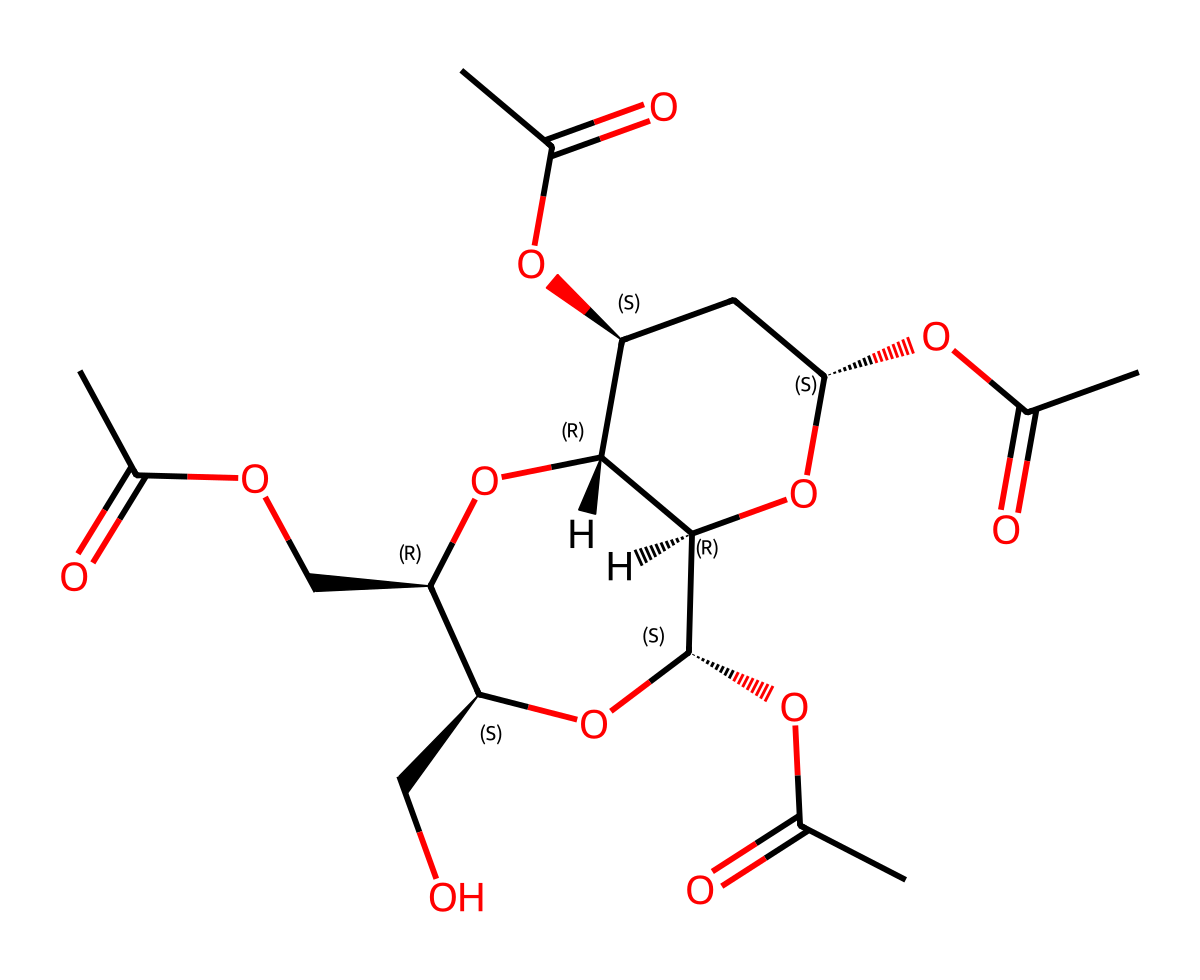What is the total number of carbon atoms in the structure? By examining the SMILES representation, count the carbon atoms indicated by "C" and "C@" in the structure. There are 12 carbon atoms in total.
Answer: 12 How many ester functional groups are present in this molecule? The structure can be analyzed for ester groups, which are characterized by the presence of the -COO- grouping. By identifying these functional groups in the structure, we can find 4 ester groups.
Answer: 4 What is the maximum number of hydroxyl (-OH) groups in the structure? Examine the structure for hydroxyl groups, looking specifically for the -OH functional group. In this case, there are 6 hydroxyl groups present in the structure.
Answer: 6 Is this molecule biodegradable? Given that the molecule is cellulose acetate, which is a biodegradable ester used in environmentally friendly applications, we can confirm that, yes, it is biodegradable.
Answer: yes What type of chemical is cellulose acetate? Cellulose acetate is identified as an ester because its structure contains ester linkages, formed by the reaction of cellulose with acetic acid.
Answer: ester What type of bonds connect the carbon atoms in cellulose acetate? Upon reviewing the structure, carbon atoms are primarily connected by single covalent bonds due to the tetrahedral arrangement around the carbon atoms.
Answer: single covalent bonds Does cellulose acetate have a cyclic structure? The analysis of the SMILES indicates a component that represents a cyclic structure, hence confirming that cellulose acetate has a cyclic part in its overall structure.
Answer: yes 